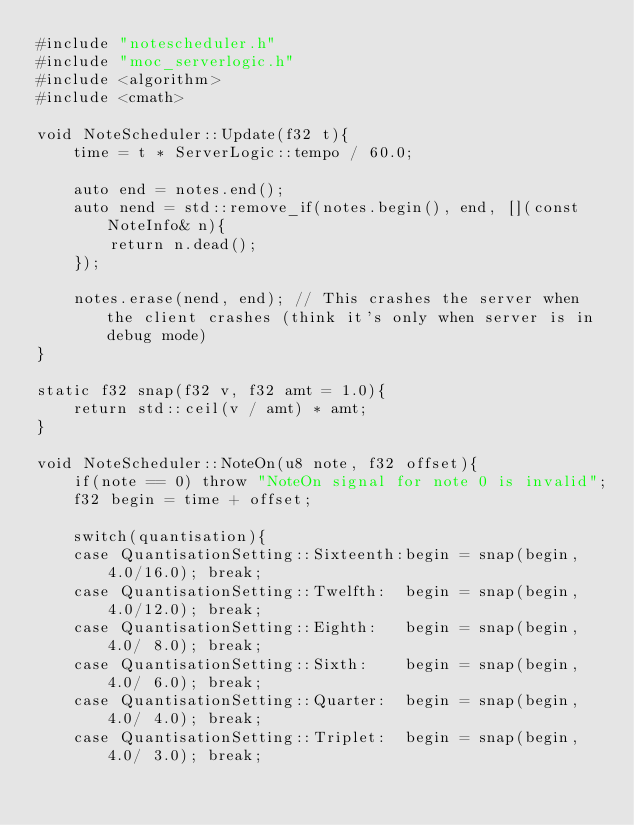Convert code to text. <code><loc_0><loc_0><loc_500><loc_500><_C++_>#include "notescheduler.h"
#include "moc_serverlogic.h"
#include <algorithm>
#include <cmath>

void NoteScheduler::Update(f32 t){
	time = t * ServerLogic::tempo / 60.0;

	auto end = notes.end();
	auto nend = std::remove_if(notes.begin(), end, [](const NoteInfo& n){
		return n.dead();
	});

	notes.erase(nend, end); // This crashes the server when the client crashes (think it's only when server is in debug mode)
}

static f32 snap(f32 v, f32 amt = 1.0){
	return std::ceil(v / amt) * amt;
}

void NoteScheduler::NoteOn(u8 note, f32 offset){
	if(note == 0) throw "NoteOn signal for note 0 is invalid";
	f32 begin = time + offset;

	switch(quantisation){
	case QuantisationSetting::Sixteenth:begin = snap(begin, 4.0/16.0); break;
	case QuantisationSetting::Twelfth: 	begin = snap(begin, 4.0/12.0); break;
	case QuantisationSetting::Eighth: 	begin = snap(begin, 4.0/ 8.0); break;
	case QuantisationSetting::Sixth: 	begin = snap(begin, 4.0/ 6.0); break;
	case QuantisationSetting::Quarter: 	begin = snap(begin, 4.0/ 4.0); break;
	case QuantisationSetting::Triplet: 	begin = snap(begin, 4.0/ 3.0); break;</code> 